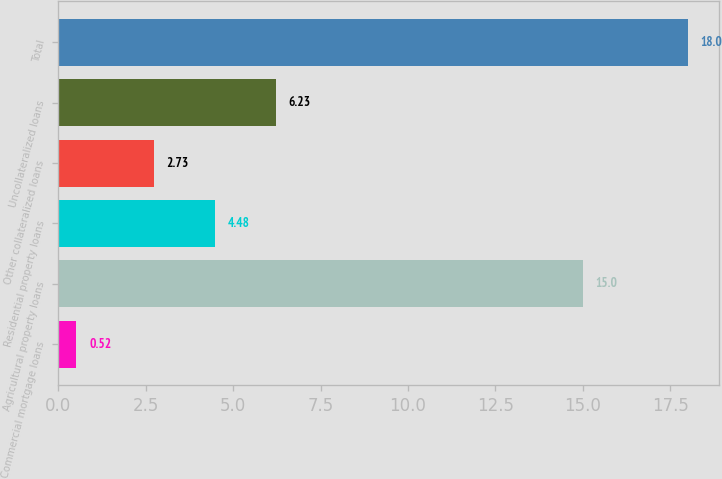Convert chart to OTSL. <chart><loc_0><loc_0><loc_500><loc_500><bar_chart><fcel>Commercial mortgage loans<fcel>Agricultural property loans<fcel>Residential property loans<fcel>Other collateralized loans<fcel>Uncollateralized loans<fcel>Total<nl><fcel>0.52<fcel>15<fcel>4.48<fcel>2.73<fcel>6.23<fcel>18<nl></chart> 